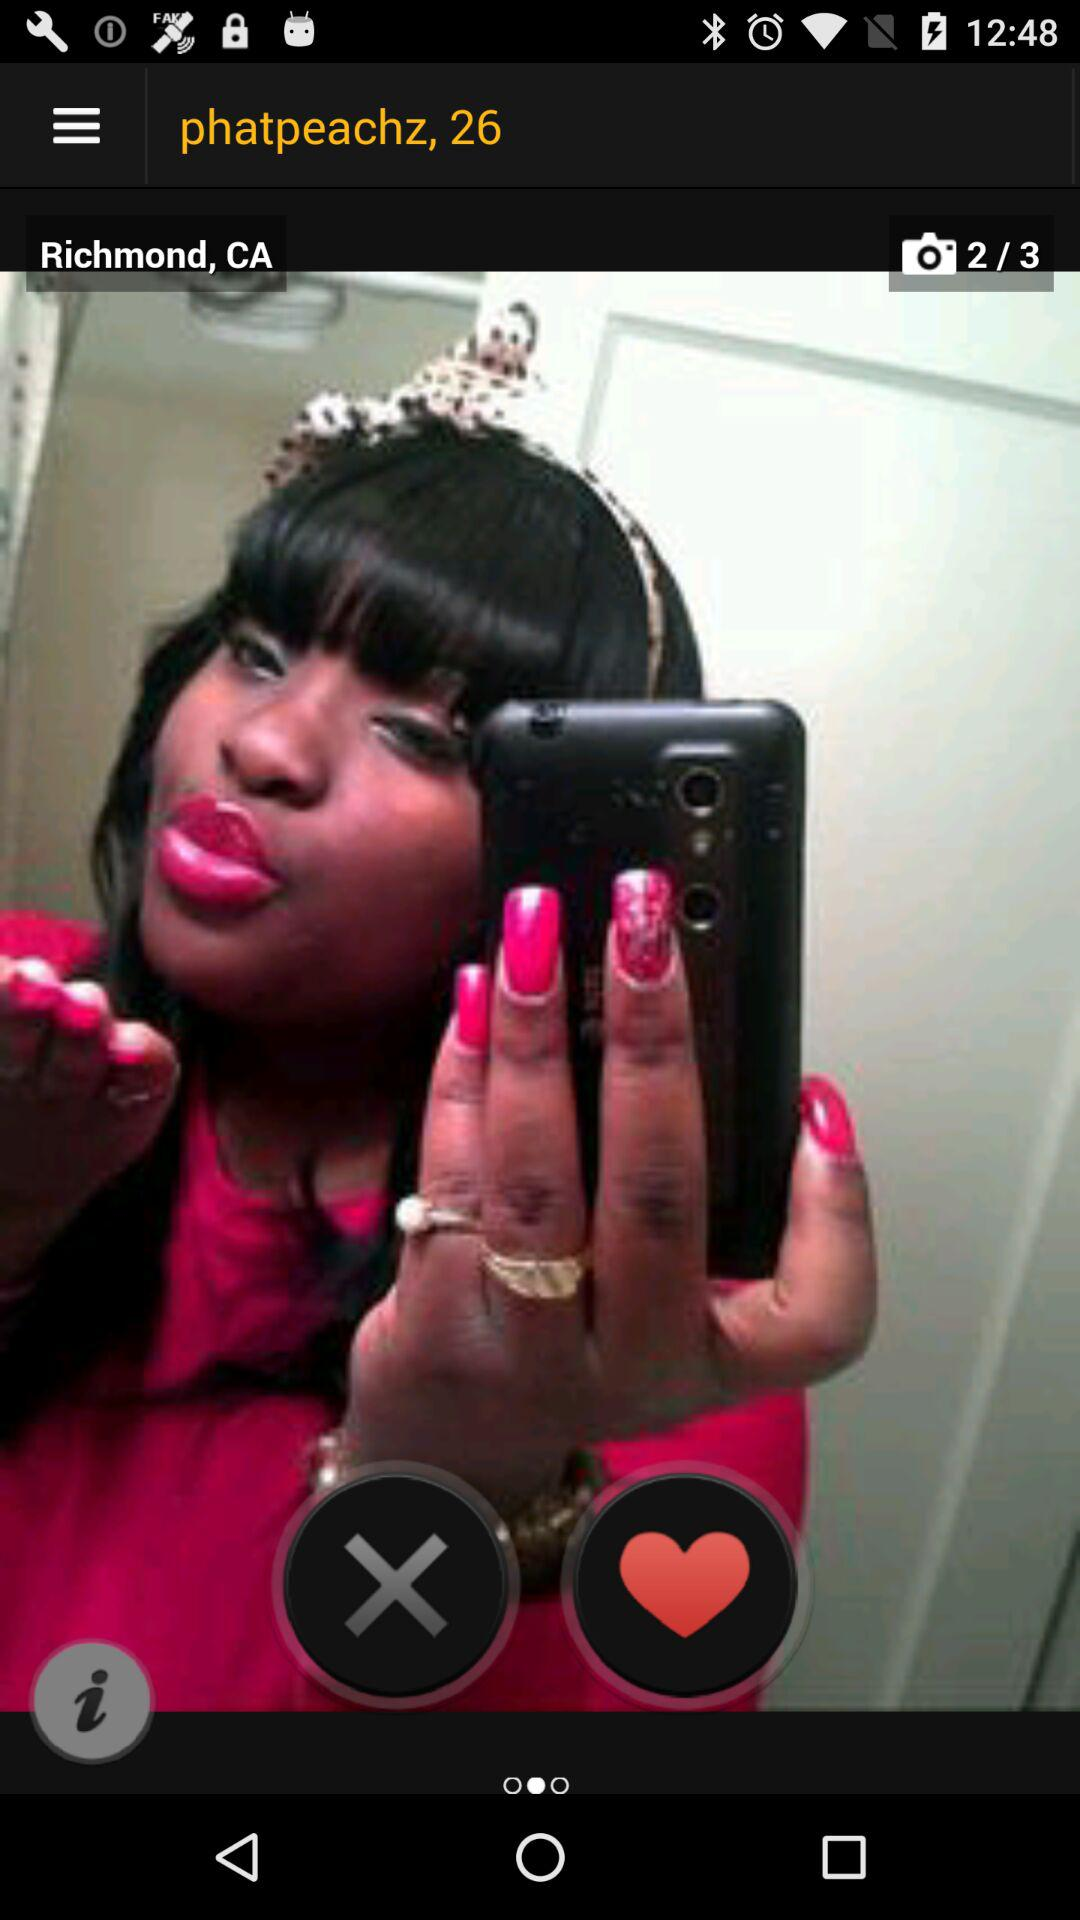What is the location of the user? The location of the user is Richmond, CA. 